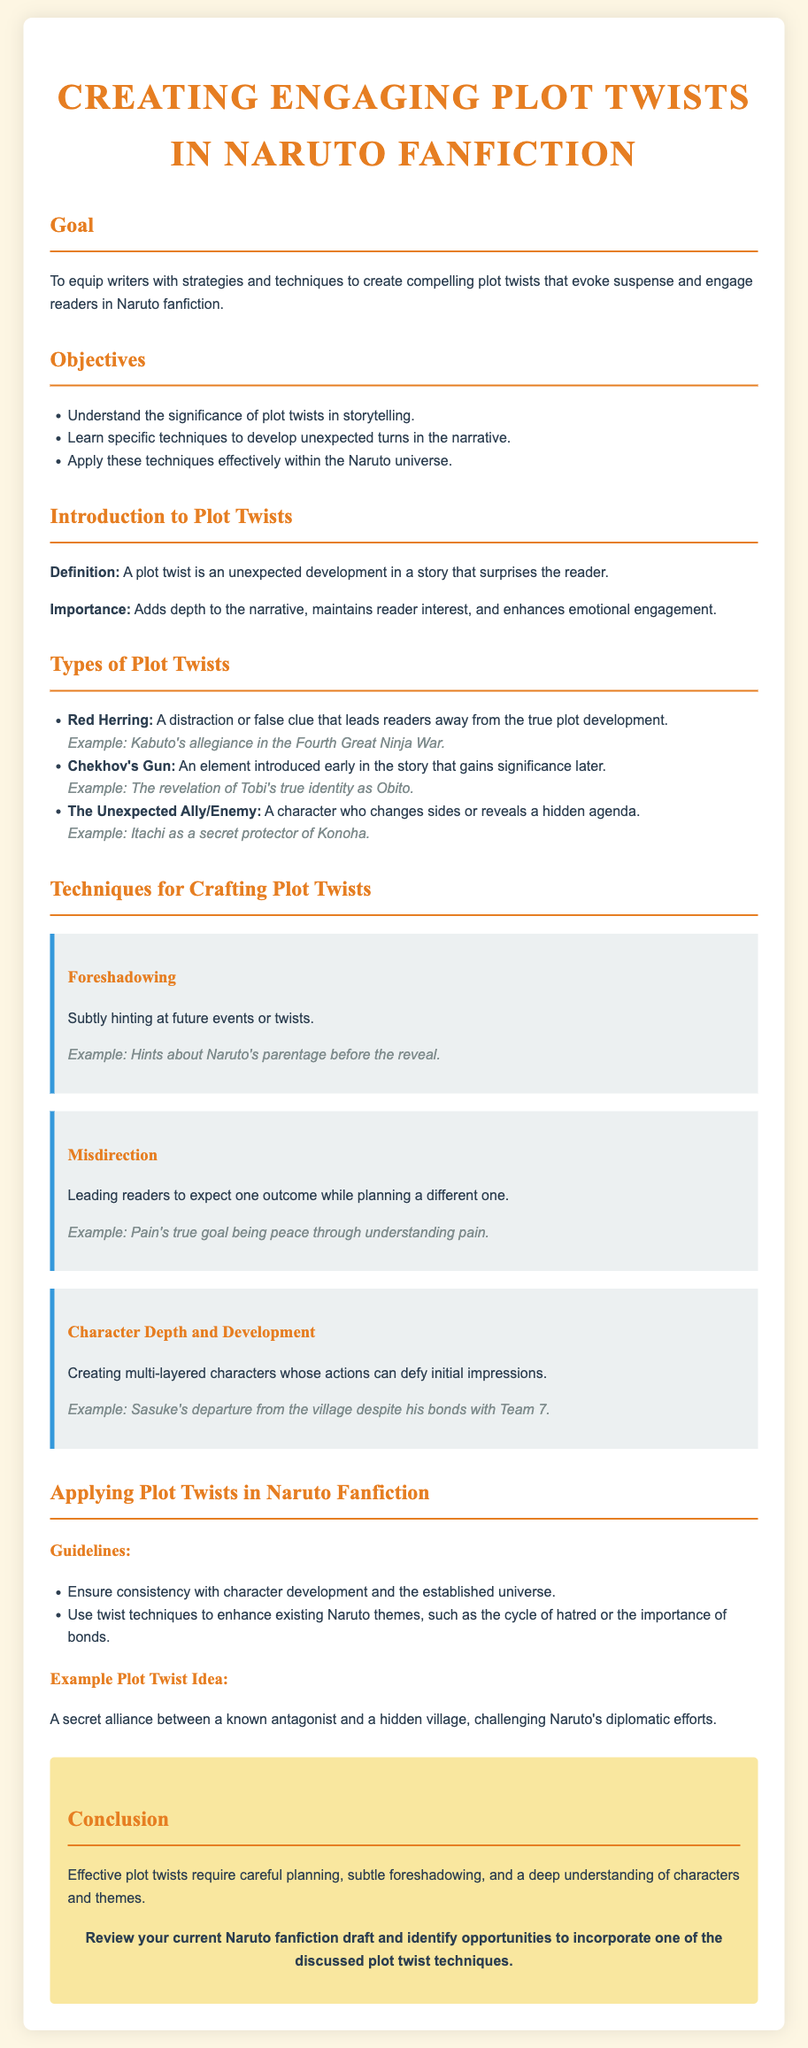What is the goal of the lesson plan? The goal is to equip writers with strategies and techniques to create compelling plot twists that evoke suspense and engage readers in Naruto fanfiction.
Answer: To equip writers with strategies and techniques to create compelling plot twists that evoke suspense and engage readers in Naruto fanfiction How many objectives are listed in the lesson plan? The number of objectives is stated explicitly in the document.
Answer: Three What type of plot twist includes a distraction or false clue? The type of plot twist is defined within the section on types of plot twists.
Answer: Red Herring Which character is mentioned as an example of Chekhov's Gun? This character is cited in the lesson plan under the type of plot twists.
Answer: Tobi What technique involves leading readers to expect one outcome while planning a different one? This technique is described in the techniques section of the document.
Answer: Misdirection In what context is Itachi mentioned? Itachi is referenced in relation to a specific type of plot twist.
Answer: The Unexpected Ally/Enemy What must writers ensure when applying plot twists in Naruto fanfiction? This guideline is given to maintain coherence and quality in the storytelling.
Answer: Consistency with character development and the established universe What is one example plot twist idea provided in the lesson? The document provides a specific scenario as an illustration of applying plot twists.
Answer: A secret alliance between a known antagonist and a hidden village, challenging Naruto's diplomatic efforts What is the key aspect that effective plot twists require? This is stated in the conclusion of the lesson plan regarding plot twists.
Answer: Careful planning 